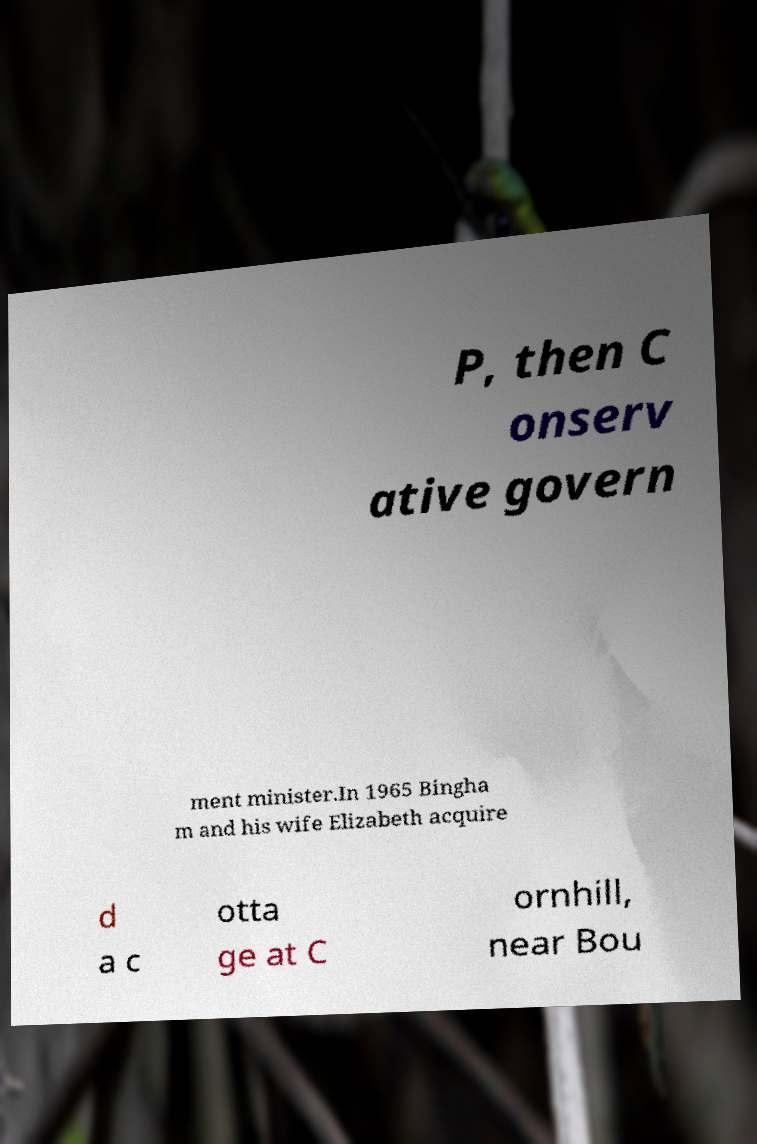What messages or text are displayed in this image? I need them in a readable, typed format. P, then C onserv ative govern ment minister.In 1965 Bingha m and his wife Elizabeth acquire d a c otta ge at C ornhill, near Bou 